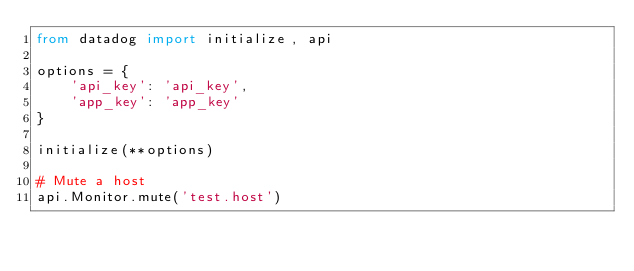Convert code to text. <code><loc_0><loc_0><loc_500><loc_500><_Python_>from datadog import initialize, api

options = {
    'api_key': 'api_key',
    'app_key': 'app_key'
}

initialize(**options)

# Mute a host
api.Monitor.mute('test.host')
</code> 